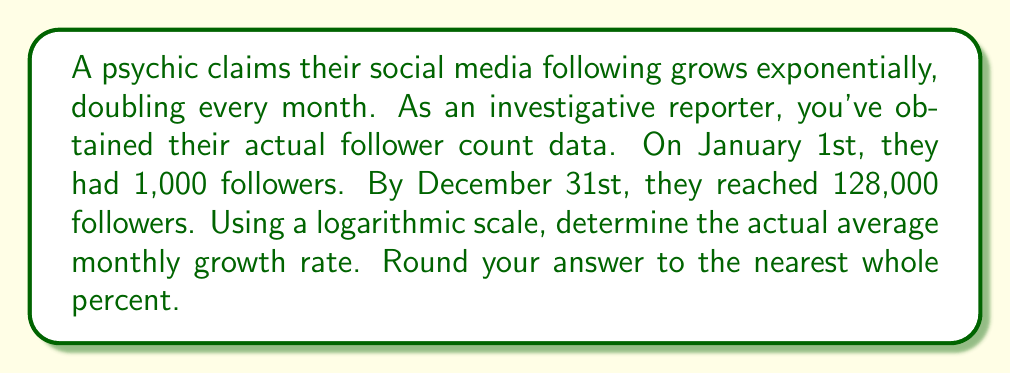Solve this math problem. Let's approach this step-by-step:

1) We'll use the exponential growth formula: $A = P(1+r)^t$
   Where A is the final amount, P is the initial amount, r is the growth rate, and t is the time period.

2) In this case:
   $A = 128,000$
   $P = 1,000$
   $t = 12$ (months)

3) Substituting these values:
   $128,000 = 1,000(1+r)^{12}$

4) Dividing both sides by 1,000:
   $128 = (1+r)^{12}$

5) Taking the logarithm of both sides:
   $\log 128 = 12 \log(1+r)$

6) Using the properties of logarithms:
   $\frac{\log 128}{12} = \log(1+r)$

7) Calculate $\log 128$:
   $\log 128 = \log 2^7 = 7 \log 2 \approx 7 \times 0.301 = 2.107$

8) Substituting:
   $\frac{2.107}{12} = \log(1+r)$

9) Solving for r:
   $1+r = 10^{\frac{2.107}{12}} \approx 1.0395$
   $r \approx 0.0395$

10) Converting to a percentage and rounding to the nearest whole percent:
    $0.0395 \times 100 \approx 3.95\% \approx 4\%$
Answer: 4% 